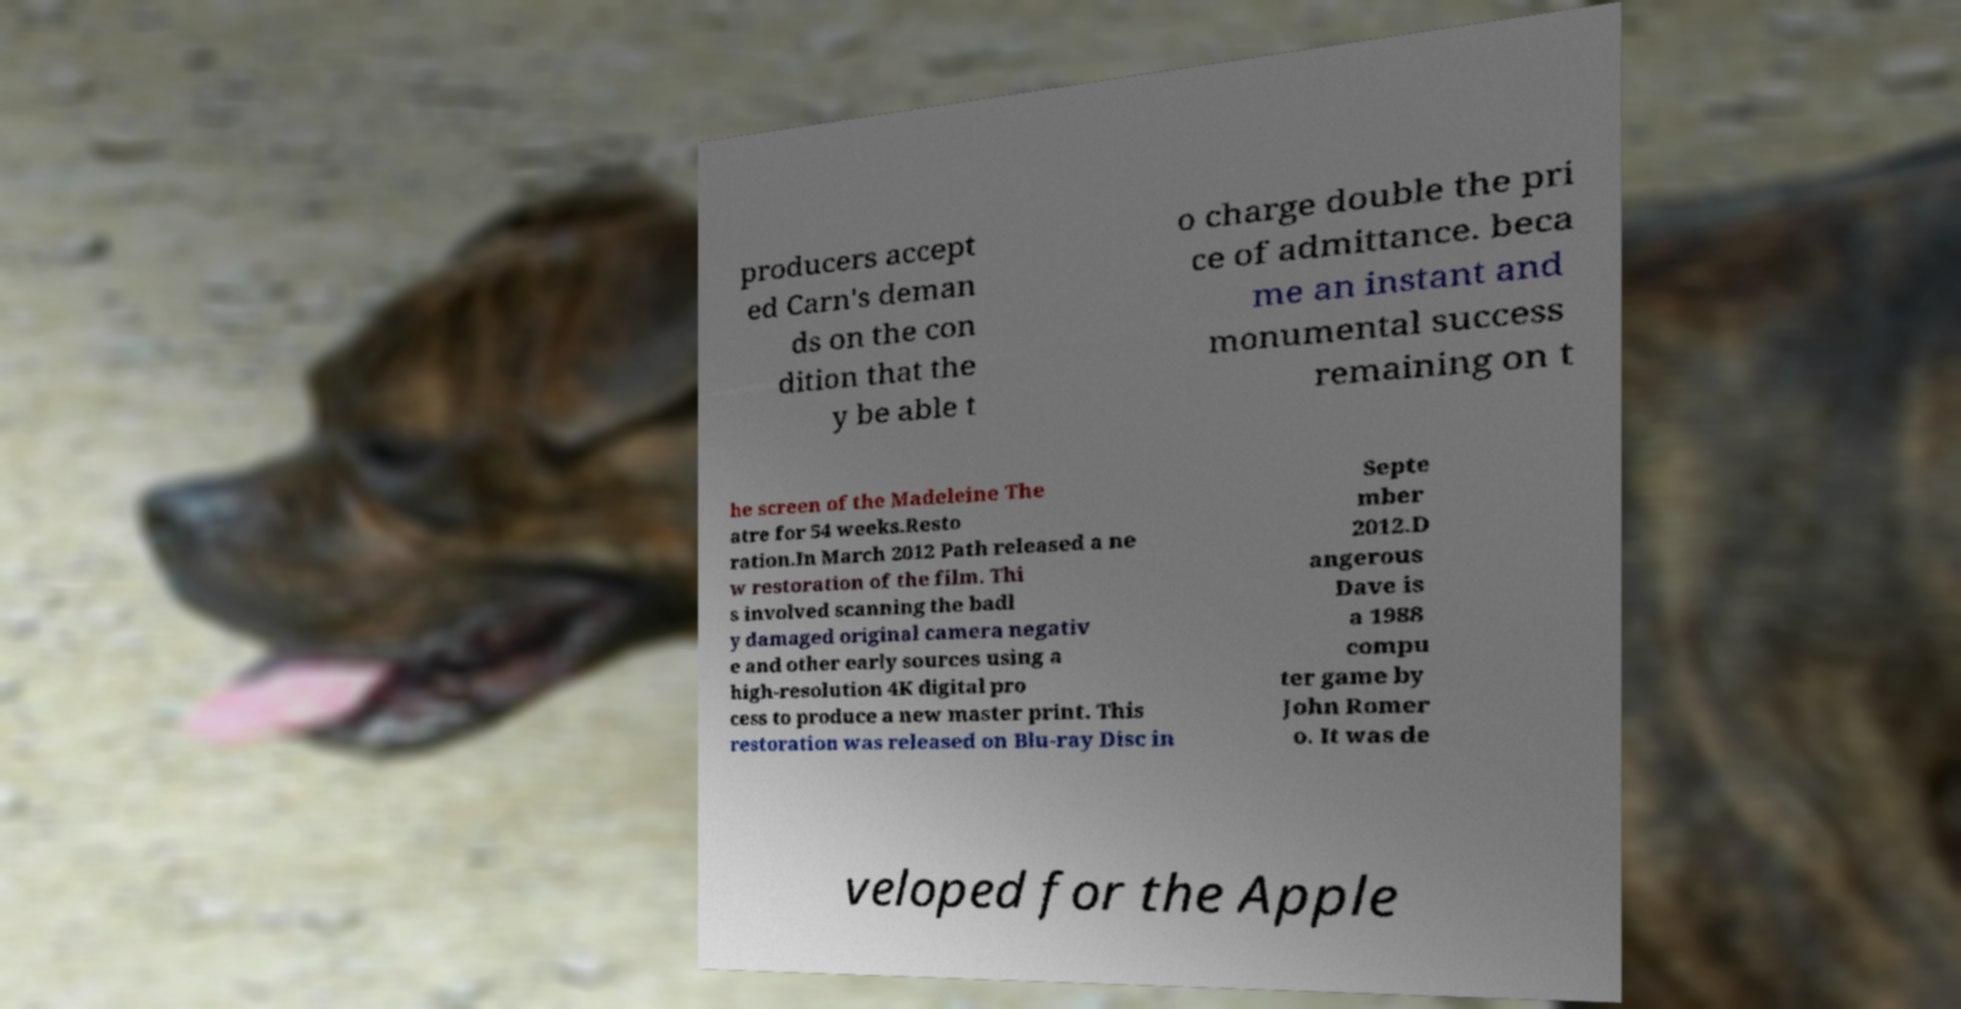Please identify and transcribe the text found in this image. producers accept ed Carn's deman ds on the con dition that the y be able t o charge double the pri ce of admittance. beca me an instant and monumental success remaining on t he screen of the Madeleine The atre for 54 weeks.Resto ration.In March 2012 Path released a ne w restoration of the film. Thi s involved scanning the badl y damaged original camera negativ e and other early sources using a high-resolution 4K digital pro cess to produce a new master print. This restoration was released on Blu-ray Disc in Septe mber 2012.D angerous Dave is a 1988 compu ter game by John Romer o. It was de veloped for the Apple 